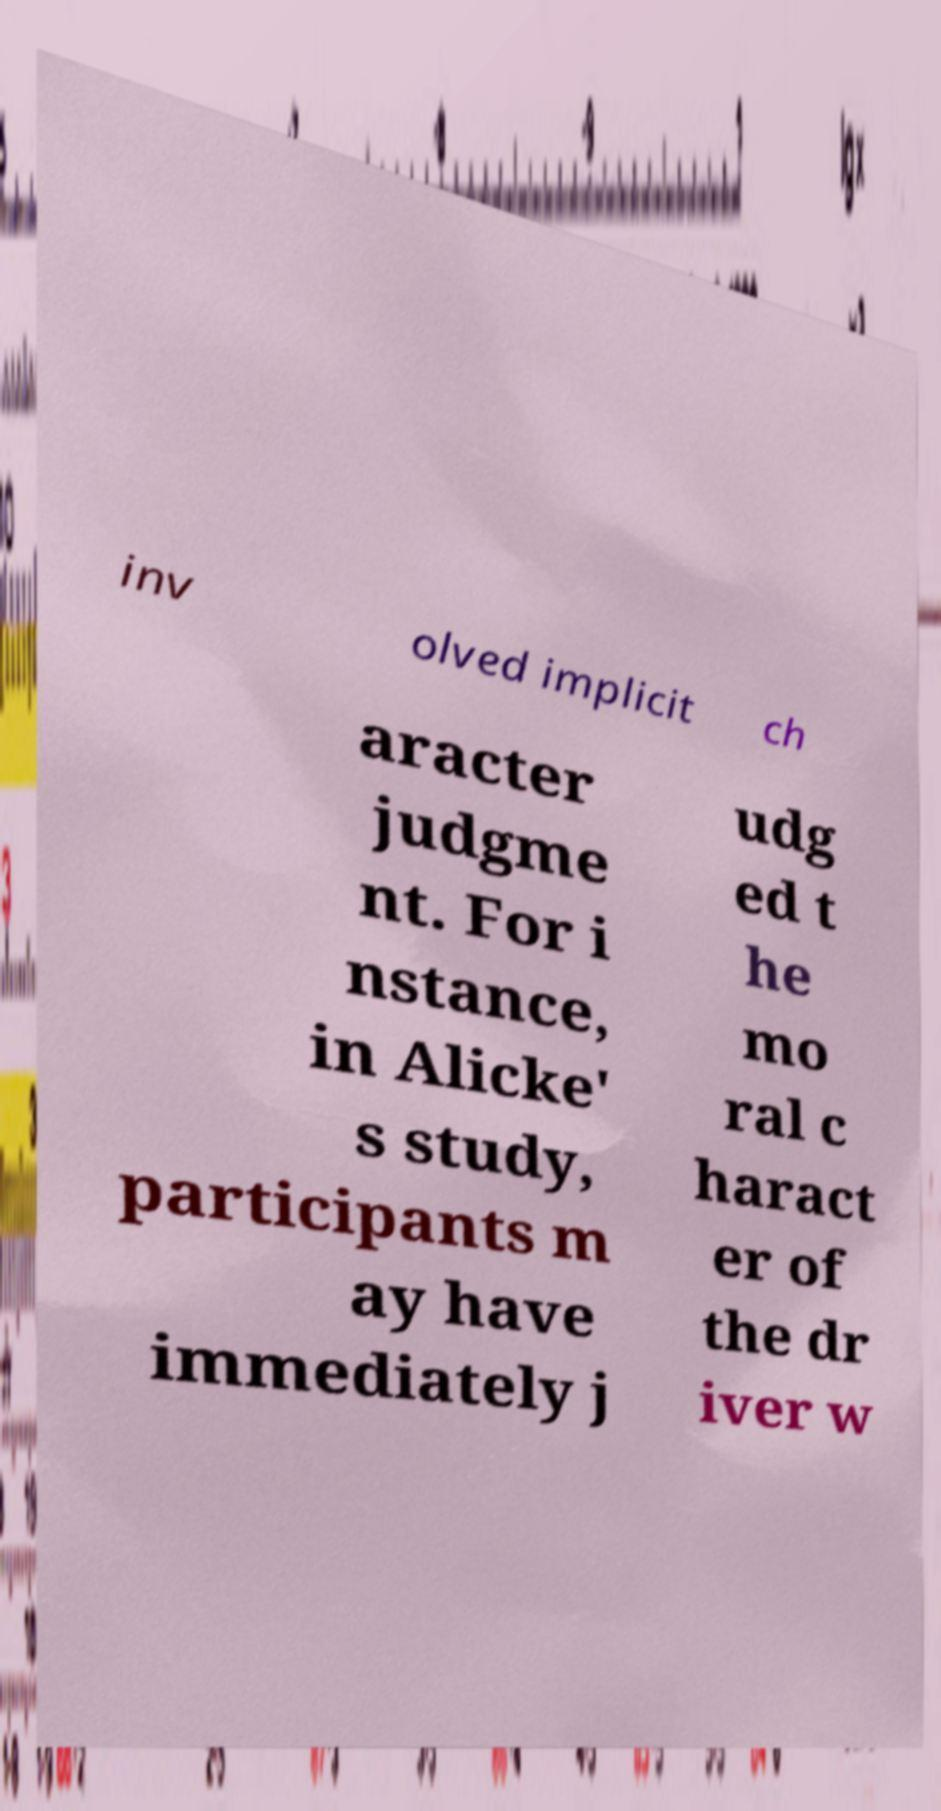Could you extract and type out the text from this image? inv olved implicit ch aracter judgme nt. For i nstance, in Alicke' s study, participants m ay have immediately j udg ed t he mo ral c haract er of the dr iver w 